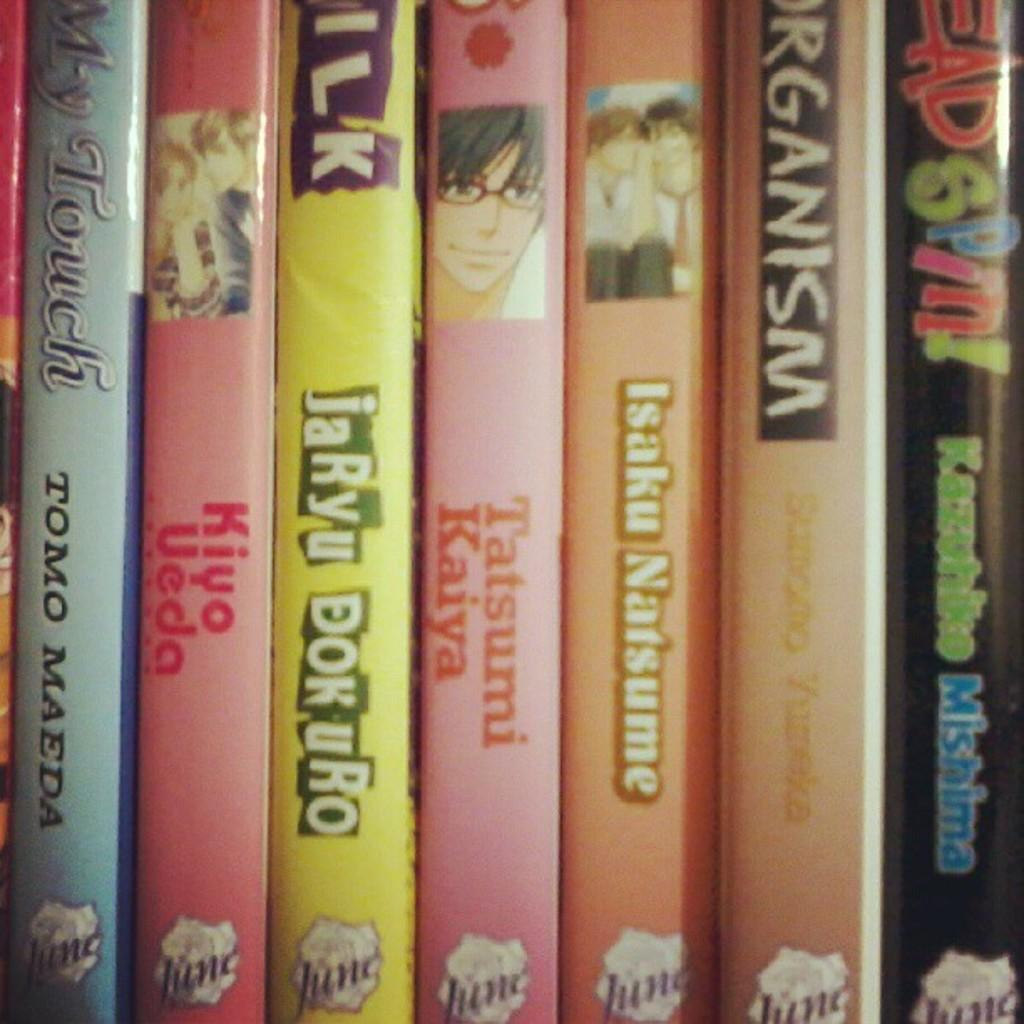<image>
Offer a succinct explanation of the picture presented. Pink book in the middle with the name "Tatsumi Kaiya" betwee nother books. 